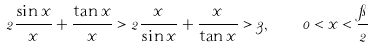<formula> <loc_0><loc_0><loc_500><loc_500>2 \frac { \sin x } { x } + \frac { \tan x } { x } > 2 \frac { x } { \sin x } + \frac { x } { \tan x } > 3 , \quad 0 < x < \frac { \pi } { 2 }</formula> 